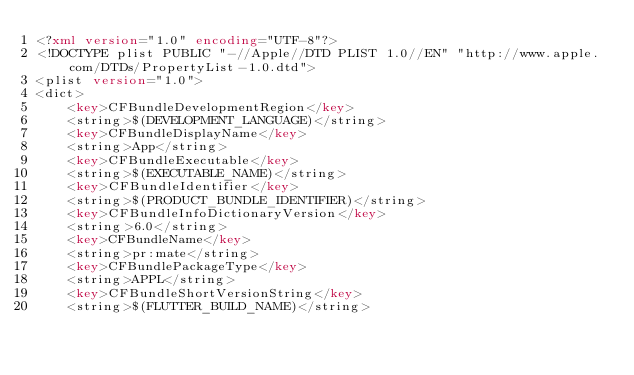<code> <loc_0><loc_0><loc_500><loc_500><_XML_><?xml version="1.0" encoding="UTF-8"?>
<!DOCTYPE plist PUBLIC "-//Apple//DTD PLIST 1.0//EN" "http://www.apple.com/DTDs/PropertyList-1.0.dtd">
<plist version="1.0">
<dict>
	<key>CFBundleDevelopmentRegion</key>
	<string>$(DEVELOPMENT_LANGUAGE)</string>
	<key>CFBundleDisplayName</key>
	<string>App</string>
	<key>CFBundleExecutable</key>
	<string>$(EXECUTABLE_NAME)</string>
	<key>CFBundleIdentifier</key>
	<string>$(PRODUCT_BUNDLE_IDENTIFIER)</string>
	<key>CFBundleInfoDictionaryVersion</key>
	<string>6.0</string>
	<key>CFBundleName</key>
	<string>pr:mate</string>
	<key>CFBundlePackageType</key>
	<string>APPL</string>
	<key>CFBundleShortVersionString</key>
	<string>$(FLUTTER_BUILD_NAME)</string></code> 